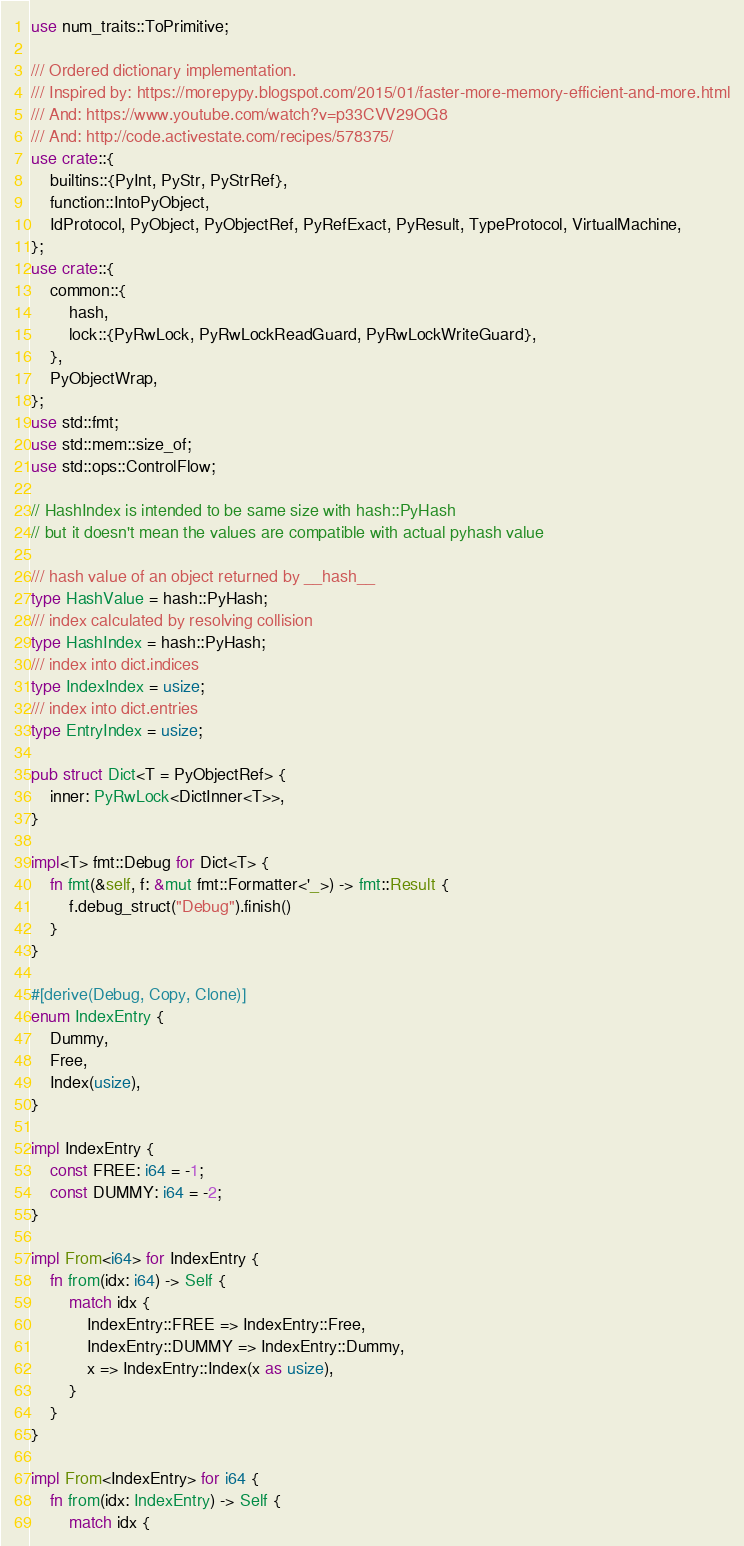<code> <loc_0><loc_0><loc_500><loc_500><_Rust_>use num_traits::ToPrimitive;

/// Ordered dictionary implementation.
/// Inspired by: https://morepypy.blogspot.com/2015/01/faster-more-memory-efficient-and-more.html
/// And: https://www.youtube.com/watch?v=p33CVV29OG8
/// And: http://code.activestate.com/recipes/578375/
use crate::{
    builtins::{PyInt, PyStr, PyStrRef},
    function::IntoPyObject,
    IdProtocol, PyObject, PyObjectRef, PyRefExact, PyResult, TypeProtocol, VirtualMachine,
};
use crate::{
    common::{
        hash,
        lock::{PyRwLock, PyRwLockReadGuard, PyRwLockWriteGuard},
    },
    PyObjectWrap,
};
use std::fmt;
use std::mem::size_of;
use std::ops::ControlFlow;

// HashIndex is intended to be same size with hash::PyHash
// but it doesn't mean the values are compatible with actual pyhash value

/// hash value of an object returned by __hash__
type HashValue = hash::PyHash;
/// index calculated by resolving collision
type HashIndex = hash::PyHash;
/// index into dict.indices
type IndexIndex = usize;
/// index into dict.entries
type EntryIndex = usize;

pub struct Dict<T = PyObjectRef> {
    inner: PyRwLock<DictInner<T>>,
}

impl<T> fmt::Debug for Dict<T> {
    fn fmt(&self, f: &mut fmt::Formatter<'_>) -> fmt::Result {
        f.debug_struct("Debug").finish()
    }
}

#[derive(Debug, Copy, Clone)]
enum IndexEntry {
    Dummy,
    Free,
    Index(usize),
}

impl IndexEntry {
    const FREE: i64 = -1;
    const DUMMY: i64 = -2;
}

impl From<i64> for IndexEntry {
    fn from(idx: i64) -> Self {
        match idx {
            IndexEntry::FREE => IndexEntry::Free,
            IndexEntry::DUMMY => IndexEntry::Dummy,
            x => IndexEntry::Index(x as usize),
        }
    }
}

impl From<IndexEntry> for i64 {
    fn from(idx: IndexEntry) -> Self {
        match idx {</code> 